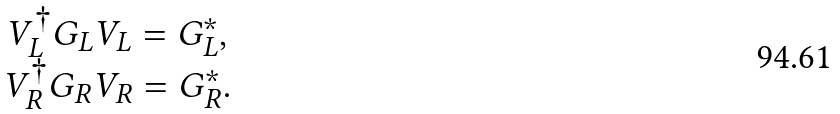<formula> <loc_0><loc_0><loc_500><loc_500>\begin{array} { c } V ^ { \dagger } _ { L } G _ { L } V _ { L } = G _ { L } ^ { * } , \\ V ^ { \dagger } _ { R } G _ { R } V _ { R } = G _ { R } ^ { * } . \end{array}</formula> 